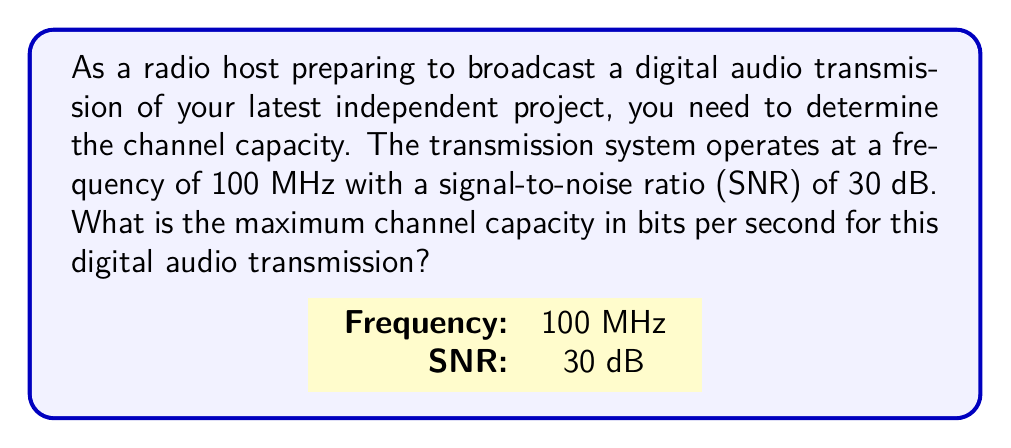Show me your answer to this math problem. To solve this problem, we'll use the Shannon-Hartley theorem, which gives the channel capacity for a communication channel subject to Gaussian noise. The steps are as follows:

1. Recall the Shannon-Hartley theorem:
   $$C = B \log_2(1 + SNR)$$
   where:
   $C$ is the channel capacity in bits per second
   $B$ is the bandwidth in Hz
   $SNR$ is the signal-to-noise ratio

2. Given:
   - Frequency = 100 MHz
   - SNR = 30 dB

3. Convert frequency to bandwidth:
   Bandwidth is typically twice the frequency for audio transmissions.
   $$B = 2 \times 100 \text{ MHz} = 200 \text{ MHz} = 200 \times 10^6 \text{ Hz}$$

4. Convert SNR from dB to linear scale:
   $$SNR_{\text{linear}} = 10^{\frac{SNR_{\text{dB}}}{10}} = 10^{\frac{30}{10}} = 1000$$

5. Apply the Shannon-Hartley theorem:
   $$\begin{align}
   C &= B \log_2(1 + SNR) \\
   &= 200 \times 10^6 \times \log_2(1 + 1000) \\
   &\approx 200 \times 10^6 \times 9.97 \\
   &\approx 1.994 \times 10^9 \text{ bits/second}
   \end{align}$$

6. Round to a reasonable precision:
   $$C \approx 1.99 \times 10^9 \text{ bits/second}$$
Answer: 1.99 Gbps 